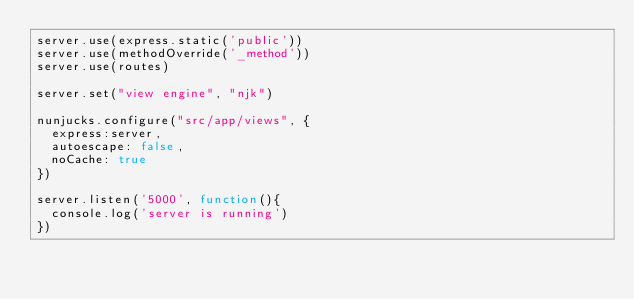Convert code to text. <code><loc_0><loc_0><loc_500><loc_500><_JavaScript_>server.use(express.static('public'))
server.use(methodOverride('_method'))
server.use(routes)

server.set("view engine", "njk")

nunjucks.configure("src/app/views", {
  express:server,
  autoescape: false,
  noCache: true
})

server.listen('5000', function(){
  console.log('server is running')
})</code> 